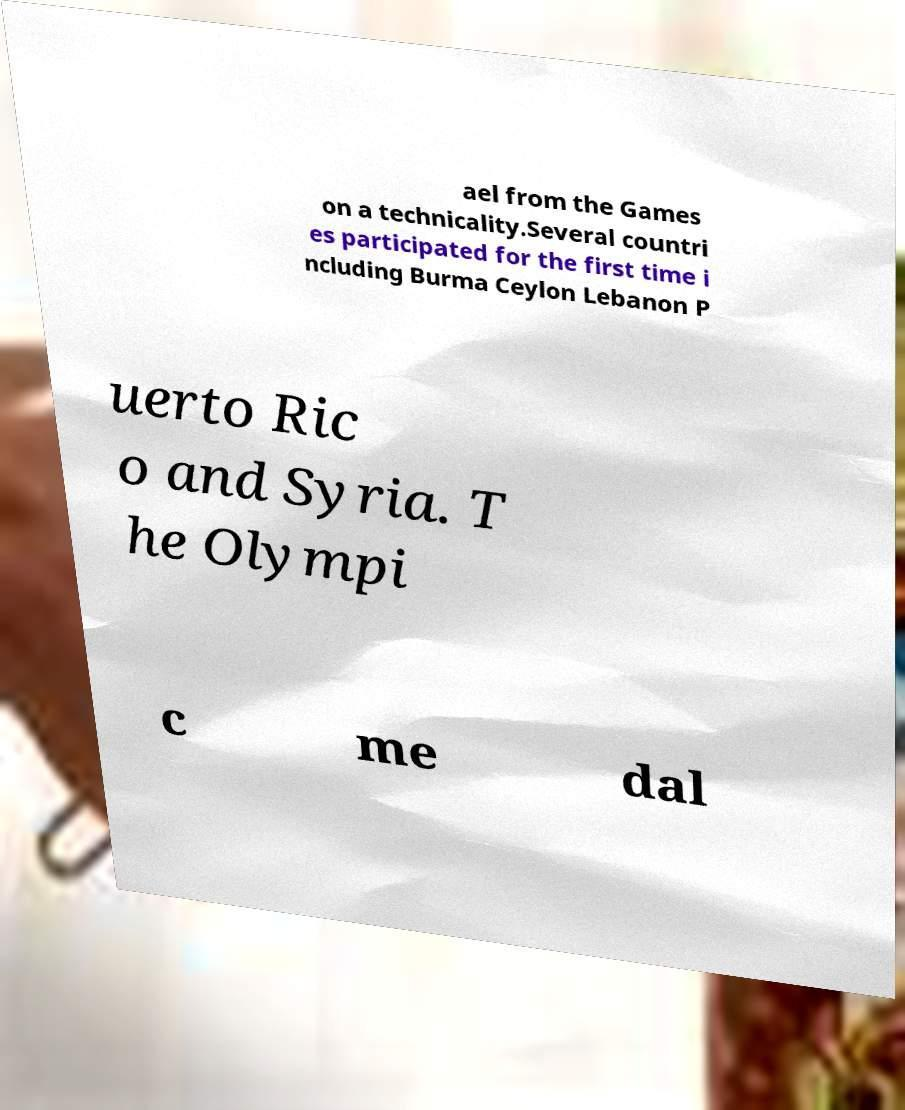What messages or text are displayed in this image? I need them in a readable, typed format. ael from the Games on a technicality.Several countri es participated for the first time i ncluding Burma Ceylon Lebanon P uerto Ric o and Syria. T he Olympi c me dal 